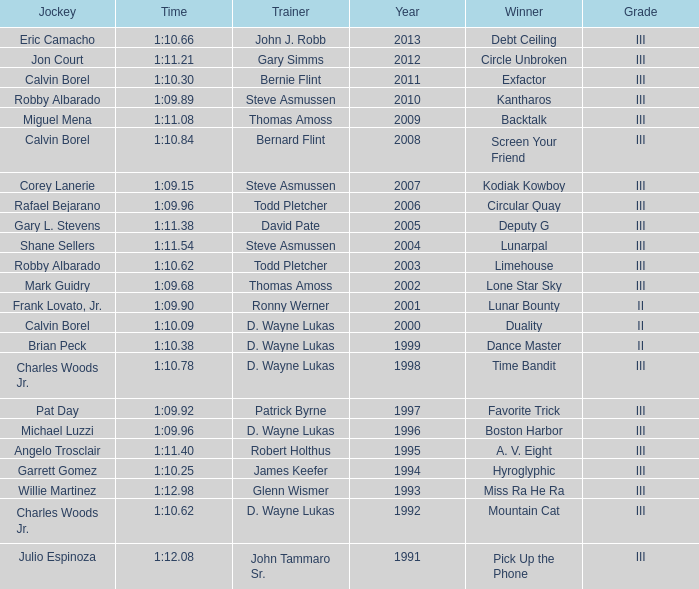Who won under Gary Simms? Circle Unbroken. 